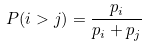Convert formula to latex. <formula><loc_0><loc_0><loc_500><loc_500>P ( i > j ) = \frac { p _ { i } } { p _ { i } + p _ { j } }</formula> 